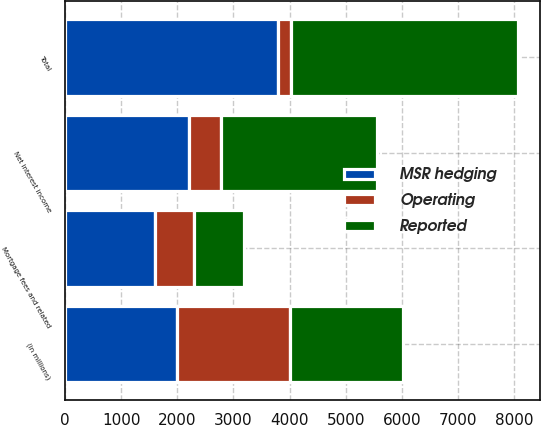<chart> <loc_0><loc_0><loc_500><loc_500><stacked_bar_chart><ecel><fcel>(in millions)<fcel>Net interest income<fcel>Mortgage fees and related<fcel>Total<nl><fcel>MSR hedging<fcel>2003<fcel>2204<fcel>1596<fcel>3800<nl><fcel>Operating<fcel>2003<fcel>575<fcel>704<fcel>230<nl><fcel>Reported<fcel>2003<fcel>2779<fcel>892<fcel>4030<nl></chart> 